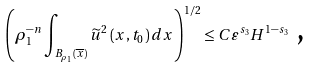Convert formula to latex. <formula><loc_0><loc_0><loc_500><loc_500>\left ( \rho _ { 1 } ^ { - n } \int \nolimits _ { B _ { \rho _ { 1 } } \left ( \overline { x } \right ) } \widetilde { u } ^ { 2 } \left ( x , t _ { 0 } \right ) d x \right ) ^ { 1 / 2 } \leq C \varepsilon ^ { s _ { 3 } } H ^ { 1 - s _ { 3 } } \text { ,}</formula> 